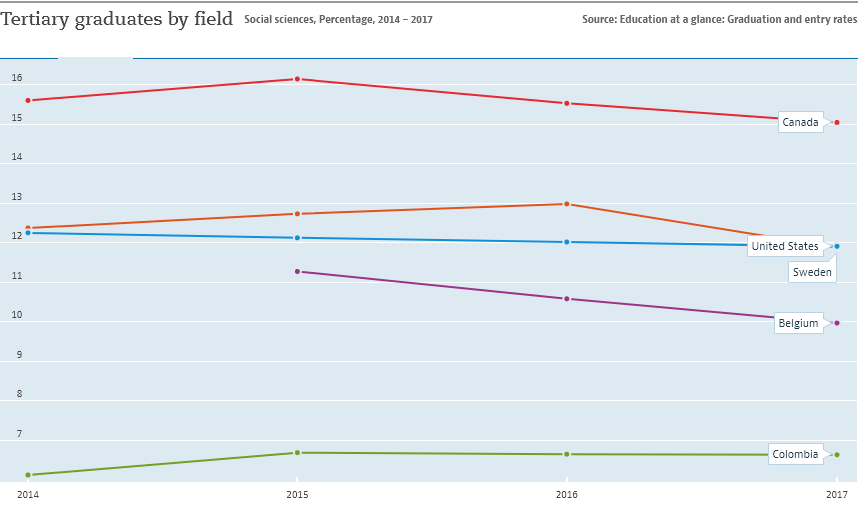Specify some key components in this picture. The gap between the United States and Sweden was at its largest in 2016. The red line in the image refers to Canada. 